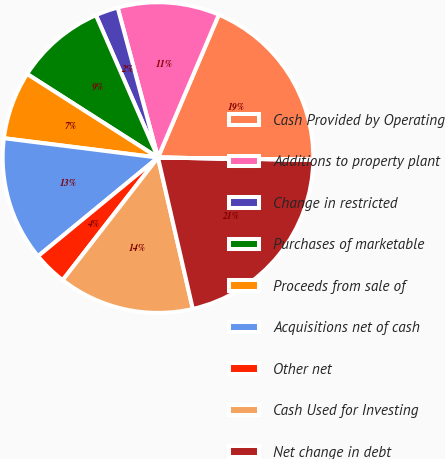Convert chart to OTSL. <chart><loc_0><loc_0><loc_500><loc_500><pie_chart><fcel>Cash Provided by Operating<fcel>Additions to property plant<fcel>Change in restricted<fcel>Purchases of marketable<fcel>Proceeds from sale of<fcel>Acquisitions net of cash<fcel>Other net<fcel>Cash Used for Investing<fcel>Net change in debt<fcel>Debt issuance costs<nl><fcel>18.82%<fcel>10.59%<fcel>2.36%<fcel>9.41%<fcel>7.06%<fcel>12.94%<fcel>3.53%<fcel>14.12%<fcel>21.17%<fcel>0.01%<nl></chart> 